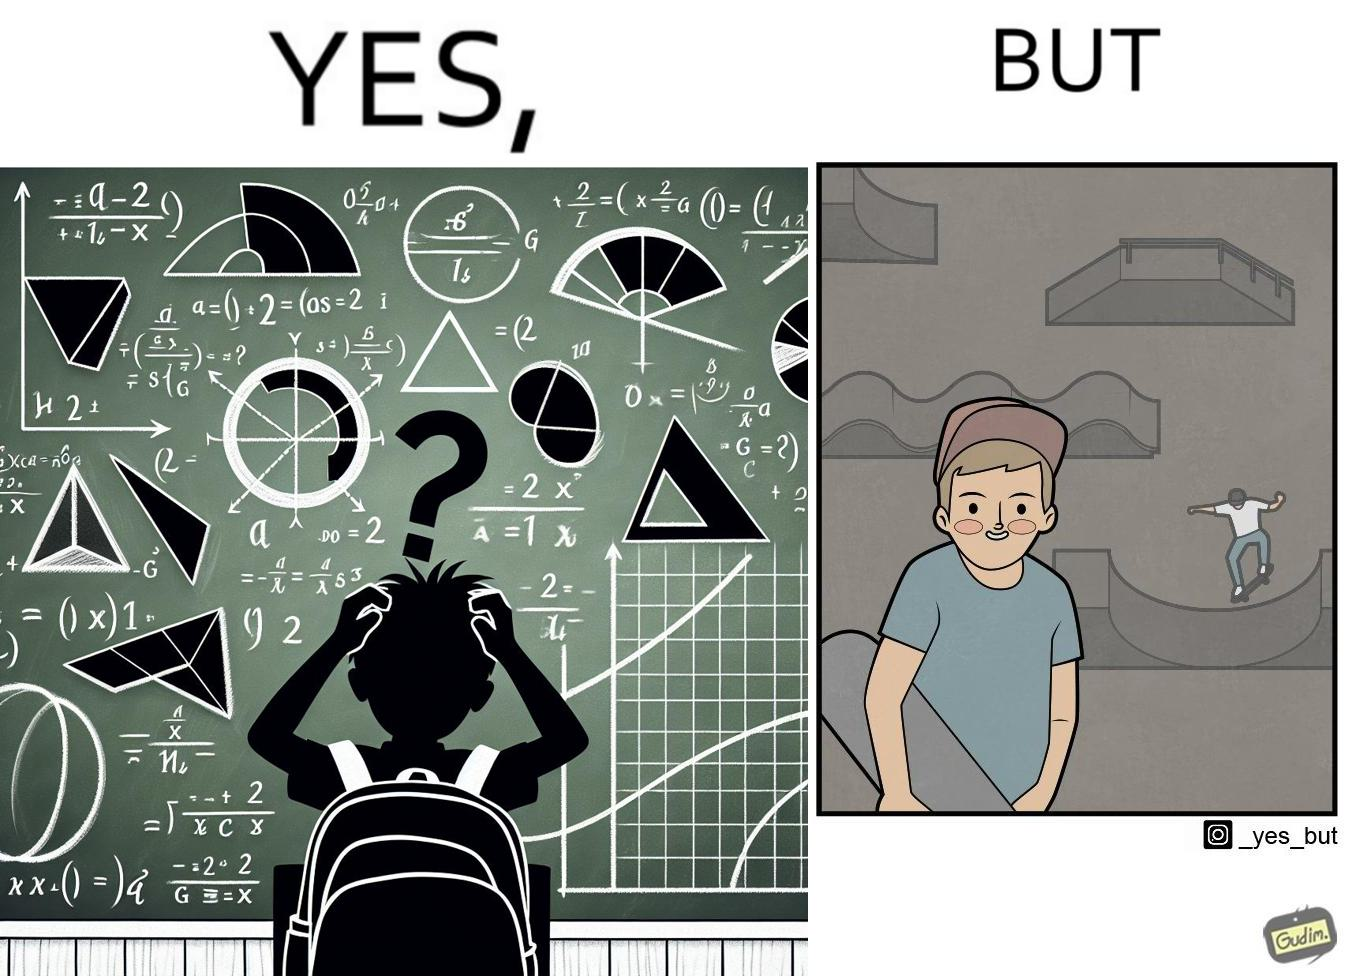What do you see in each half of this image? In the left part of the image: The image shows a boy annoyed with studying maths. Behind him is a board with lots of shapes like  semi-circle and trapezoid drawn along with mathematical formulas like areas of circle. There is a graph of sinusodial curve also drawn on the board. In the right part of the image: The image shows a boy wearing a cap with a skateboard in his hands. He is happy. In his background there is a skateboard park. In the background there is a person skateboarding on a semi cirular bowl. We also see bowls of other shapes like trapezoid and sine wave. 